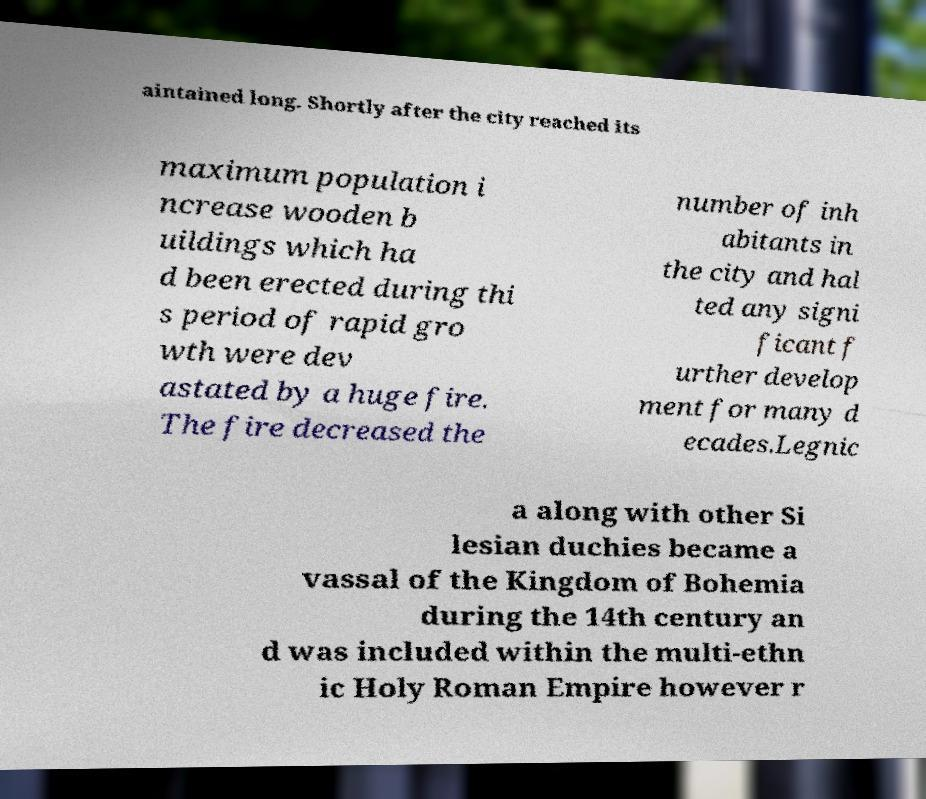There's text embedded in this image that I need extracted. Can you transcribe it verbatim? aintained long. Shortly after the city reached its maximum population i ncrease wooden b uildings which ha d been erected during thi s period of rapid gro wth were dev astated by a huge fire. The fire decreased the number of inh abitants in the city and hal ted any signi ficant f urther develop ment for many d ecades.Legnic a along with other Si lesian duchies became a vassal of the Kingdom of Bohemia during the 14th century an d was included within the multi-ethn ic Holy Roman Empire however r 